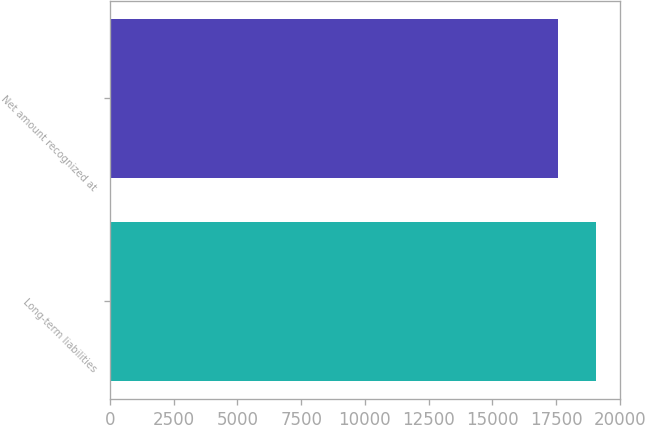Convert chart. <chart><loc_0><loc_0><loc_500><loc_500><bar_chart><fcel>Long-term liabilities<fcel>Net amount recognized at<nl><fcel>19062<fcel>17570<nl></chart> 